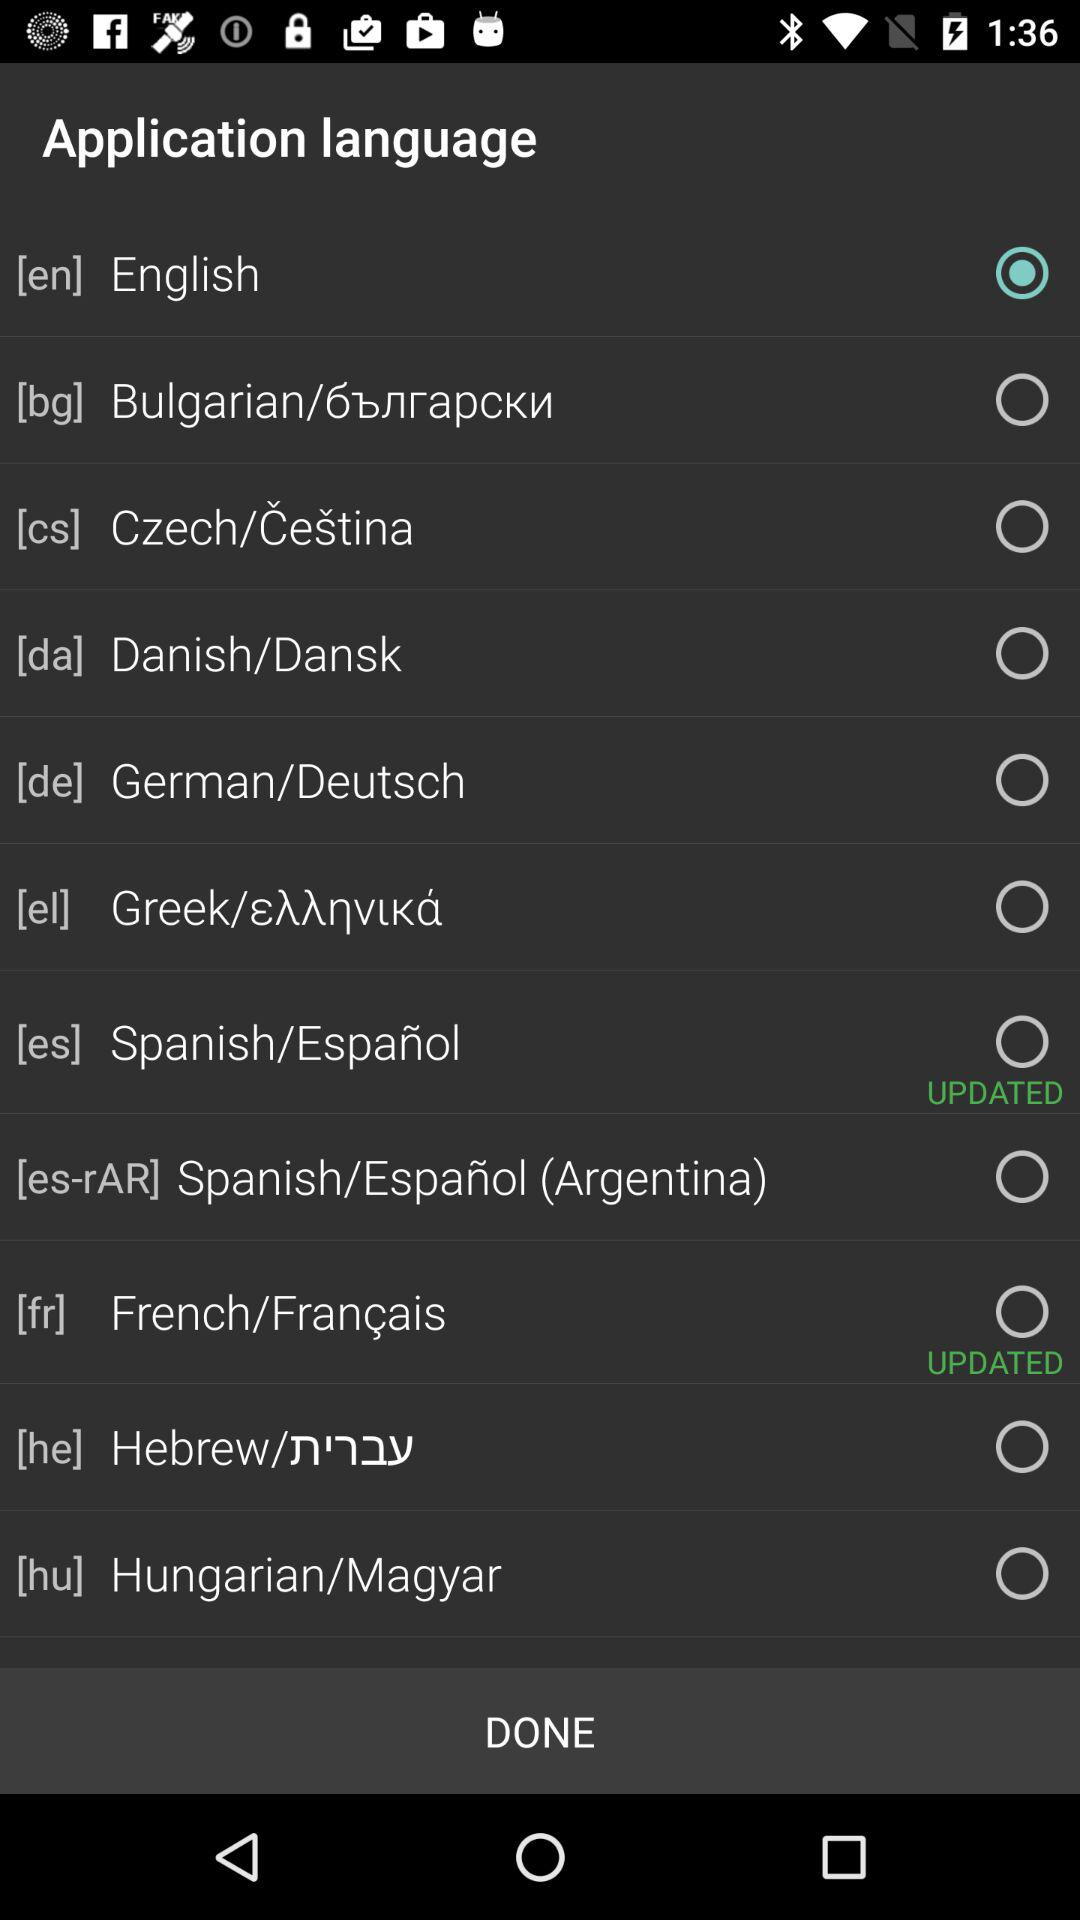How many languages are available for selection?
Answer the question using a single word or phrase. 10 